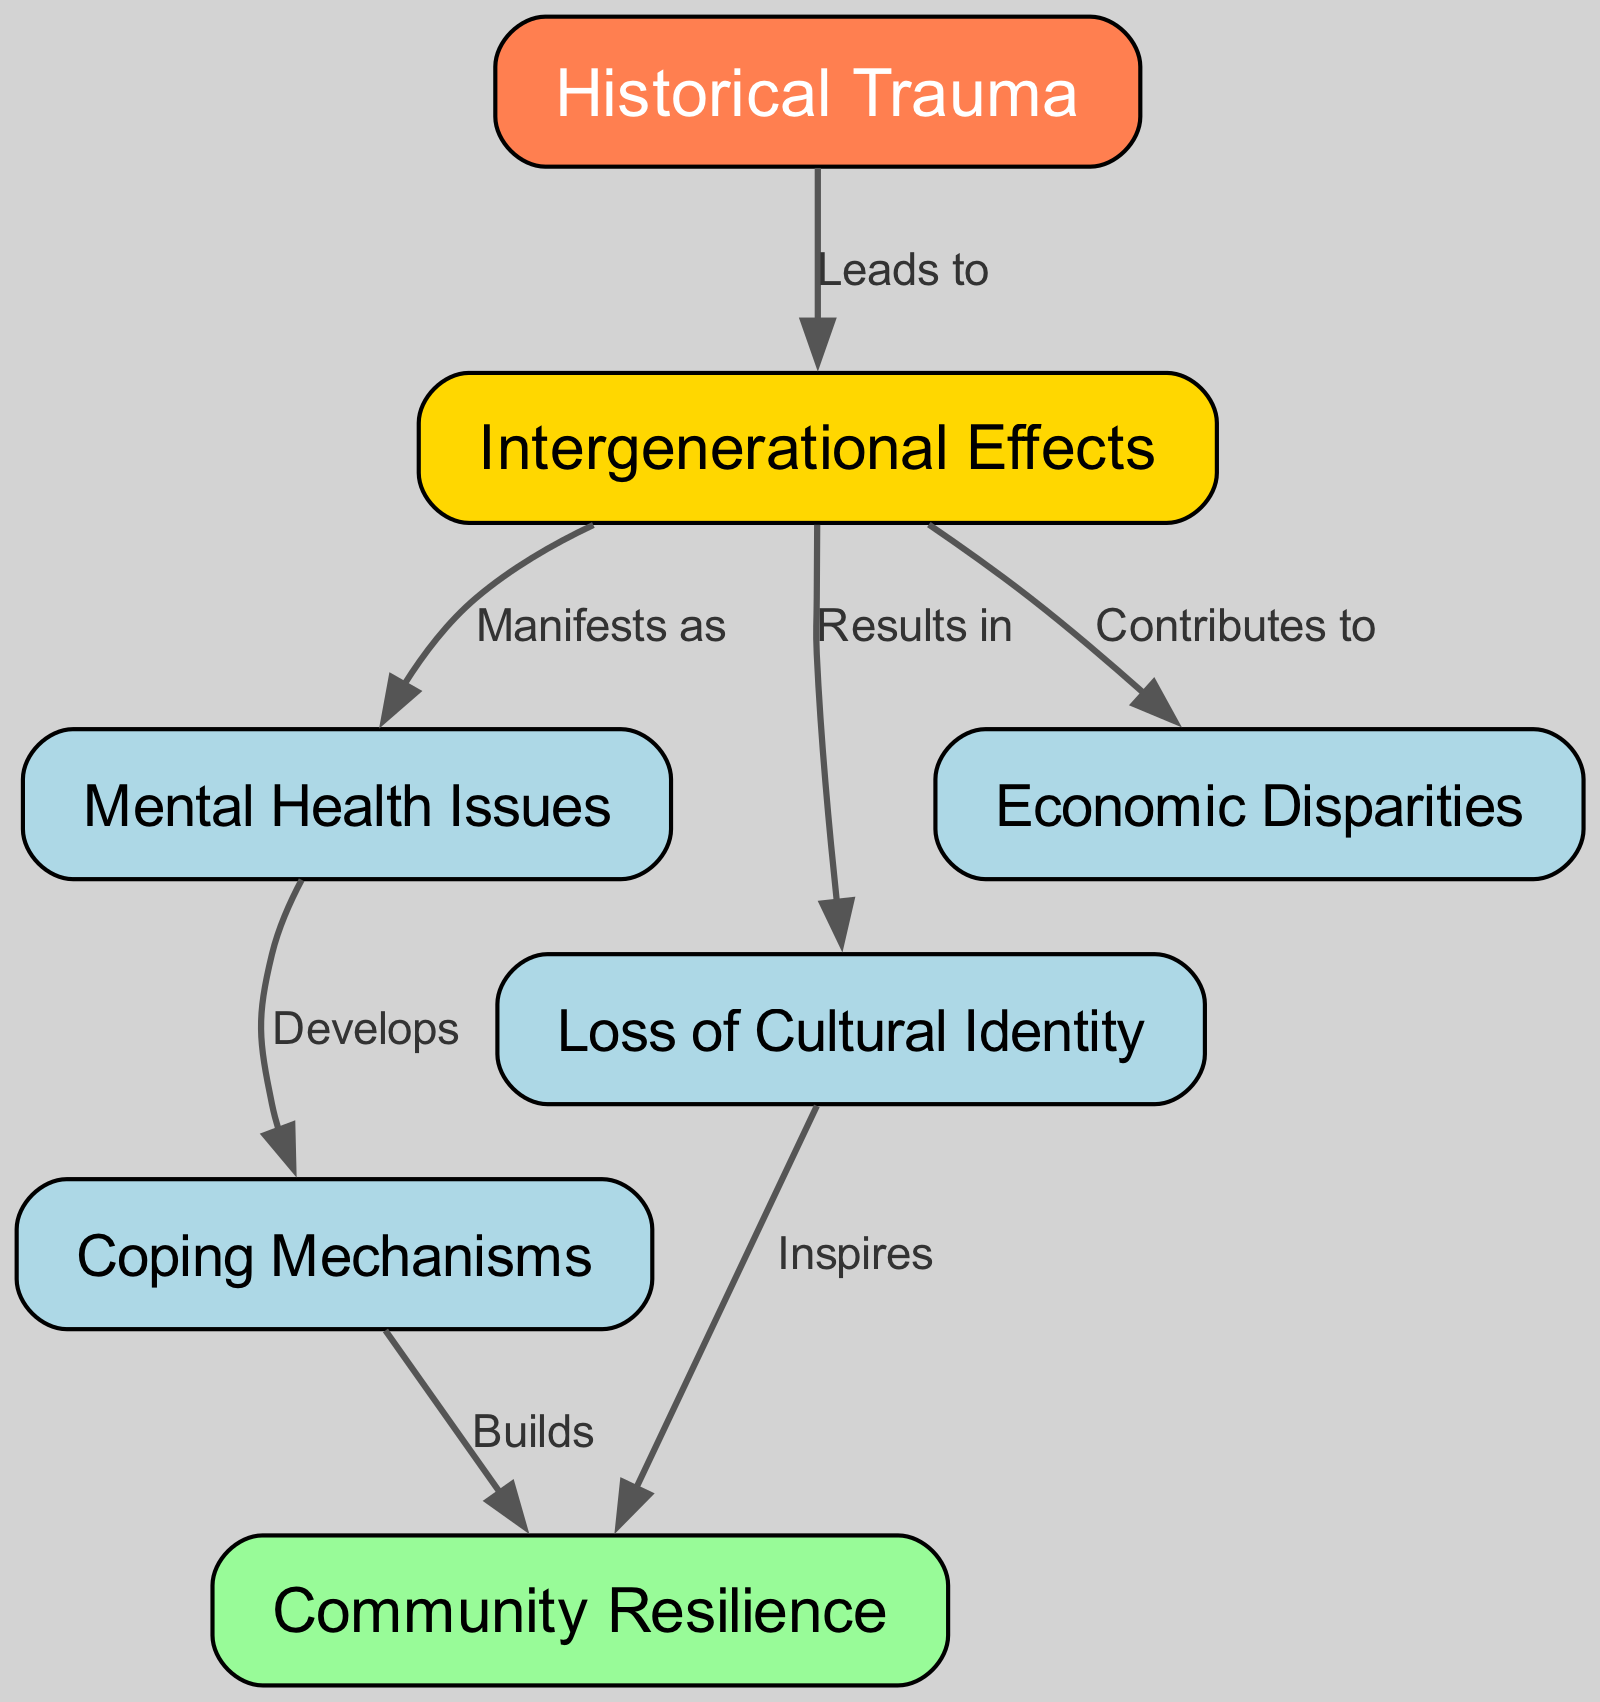What is the main topic of the diagram? The central theme of the diagram is indicated by the first node, which is labeled "Historical Trauma." This node serves as the starting point from which other related concepts emerge.
Answer: Historical Trauma How many nodes are present in the diagram? To find the number of nodes, we count all the distinct nodes listed in the data. There are a total of 7 nodes: Historical Trauma, Intergenerational Effects, Mental Health Issues, Loss of Cultural Identity, Economic Disparities, Coping Mechanisms, and Community Resilience.
Answer: 7 What relationship connects "Historical Trauma" and "Intergenerational Effects"? The edge connecting these two nodes is labeled "Leads to," indicating a direct relationship where Historical Trauma is the cause and Intergenerational Effects is the result.
Answer: Leads to Which node results in cultural loss? The edge from "Intergenerational Effects" to "Loss of Cultural Identity" indicates that cultural loss is a direct result of intergenerational effects experienced by marginalized communities.
Answer: Results in What does "Mental Health Issues" develop into? The edge leading from "Mental Health Issues" to "Coping Mechanisms" shows that mental health issues lead individuals to develop coping mechanisms to manage their experiences.
Answer: Develops How does "Cultural Loss" influence "Community Resilience"? The diagram shows an edge labeled "Inspires" that connects "Cultural Loss" to "Community Resilience." This implies that the loss of cultural identity could motivate or inspire communities to become more resilient in facing challenges.
Answer: Inspires What does "Coping Mechanisms" build? There is a directed edge leading from "Coping Mechanisms" to "Community Resilience," labeled "Builds," indicating that effective coping mechanisms contribute to the development of resilience within the community.
Answer: Builds Which two nodes are connected by an edge labeled "Contributes to"? The edge labeled "Contributes to" connects the nodes "Intergenerational Effects" and "Economic Disparities," showing that the effects of historical trauma contribute to existing economic disparities in marginalized communities.
Answer: Contributes to 